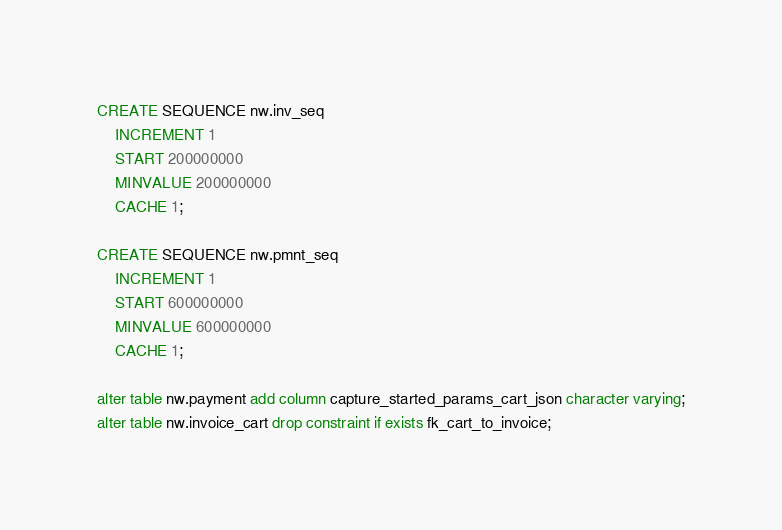<code> <loc_0><loc_0><loc_500><loc_500><_SQL_>CREATE SEQUENCE nw.inv_seq
    INCREMENT 1
    START 200000000
    MINVALUE 200000000
    CACHE 1;

CREATE SEQUENCE nw.pmnt_seq
    INCREMENT 1
    START 600000000
    MINVALUE 600000000
    CACHE 1;

alter table nw.payment add column capture_started_params_cart_json character varying;
alter table nw.invoice_cart drop constraint if exists fk_cart_to_invoice;</code> 